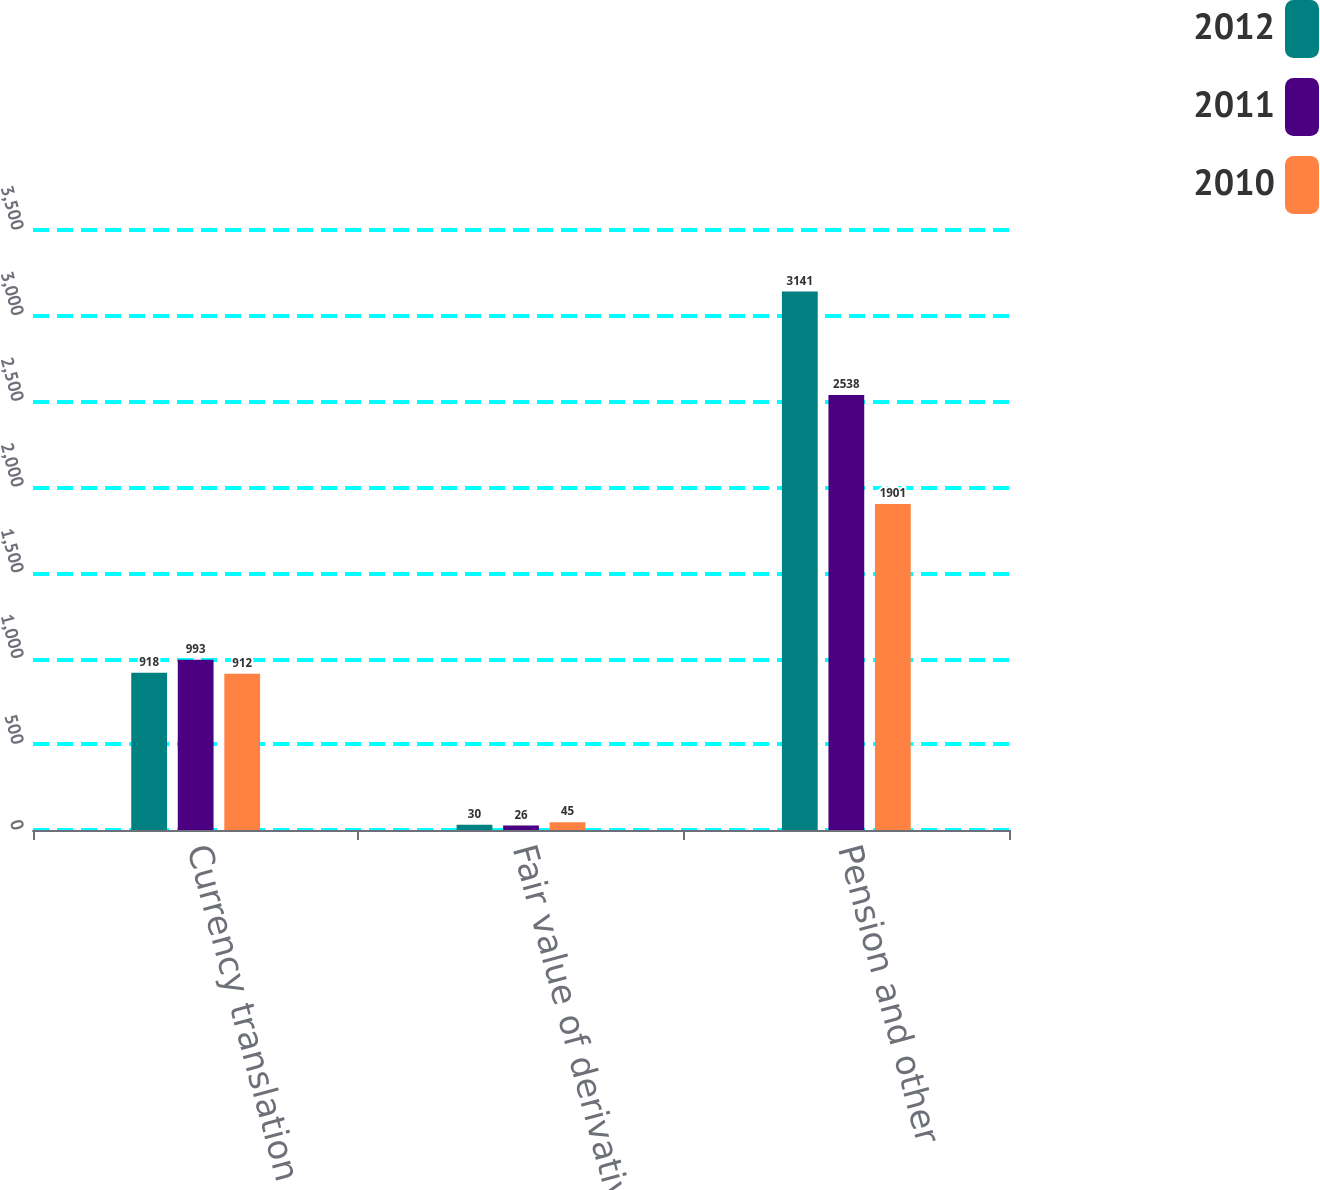Convert chart. <chart><loc_0><loc_0><loc_500><loc_500><stacked_bar_chart><ecel><fcel>Currency translation<fcel>Fair value of derivatives<fcel>Pension and other<nl><fcel>2012<fcel>918<fcel>30<fcel>3141<nl><fcel>2011<fcel>993<fcel>26<fcel>2538<nl><fcel>2010<fcel>912<fcel>45<fcel>1901<nl></chart> 